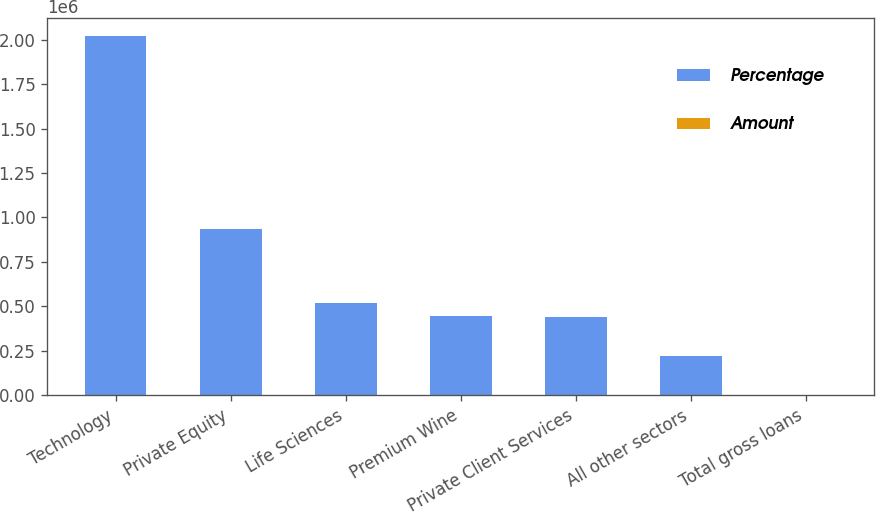<chart> <loc_0><loc_0><loc_500><loc_500><stacked_bar_chart><ecel><fcel>Technology<fcel>Private Equity<fcel>Life Sciences<fcel>Premium Wine<fcel>Private Client Services<fcel>All other sectors<fcel>Total gross loans<nl><fcel>Percentage<fcel>2.02389e+06<fcel>936693<fcel>519791<fcel>442061<fcel>440018<fcel>220516<fcel>100<nl><fcel>Amount<fcel>44.2<fcel>20.4<fcel>11.3<fcel>9.7<fcel>9.6<fcel>4.8<fcel>100<nl></chart> 